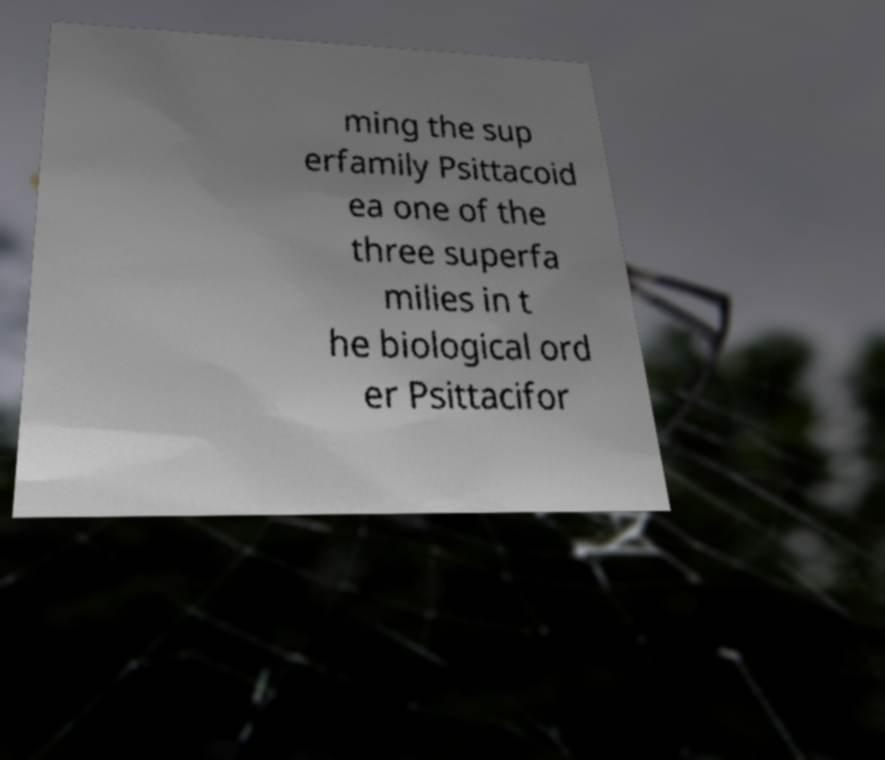Could you assist in decoding the text presented in this image and type it out clearly? ming the sup erfamily Psittacoid ea one of the three superfa milies in t he biological ord er Psittacifor 